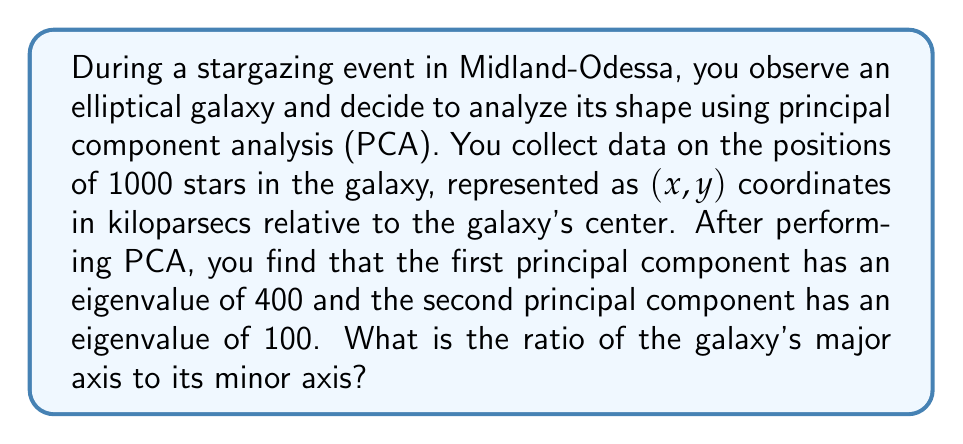Give your solution to this math problem. To solve this problem, we'll follow these steps:

1) In PCA, the eigenvalues represent the amount of variance explained by each principal component. The larger the eigenvalue, the more variance it explains.

2) For an elliptical galaxy, the first principal component corresponds to the major axis, and the second principal component corresponds to the minor axis.

3) The square root of an eigenvalue is proportional to the length of the corresponding axis. Let's call the length of the major axis $a$ and the length of the minor axis $b$.

   $$a \propto \sqrt{400} = 20$$
   $$b \propto \sqrt{100} = 10$$

4) The ratio of the major axis to the minor axis is therefore:

   $$\frac{a}{b} = \frac{20}{10} = 2$$

This means the major axis is twice as long as the minor axis.

5) We can verify this result by considering that the ratio of the variances (eigenvalues) is:

   $$\frac{400}{100} = 4$$

   And the square root of this ratio should equal our axis ratio:

   $$\sqrt{4} = 2$$

Thus, the ratio of the galaxy's major axis to its minor axis is 2:1.
Answer: The ratio of the galaxy's major axis to its minor axis is 2:1. 